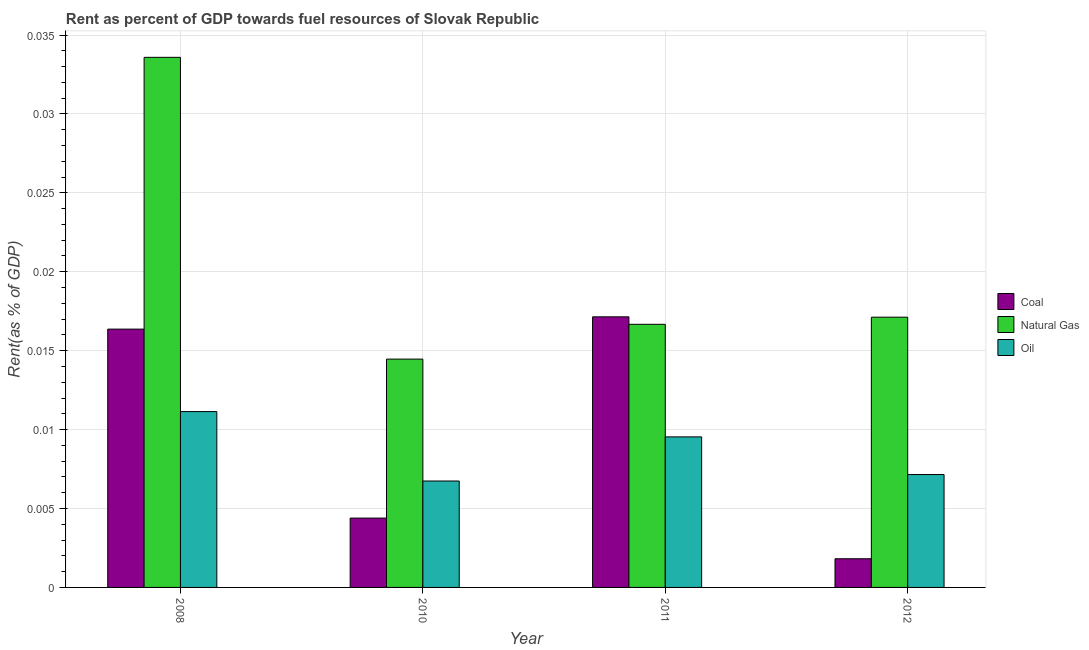Are the number of bars on each tick of the X-axis equal?
Your answer should be very brief. Yes. How many bars are there on the 2nd tick from the left?
Offer a very short reply. 3. How many bars are there on the 1st tick from the right?
Your response must be concise. 3. What is the label of the 2nd group of bars from the left?
Keep it short and to the point. 2010. What is the rent towards coal in 2008?
Your answer should be compact. 0.02. Across all years, what is the maximum rent towards oil?
Your answer should be compact. 0.01. Across all years, what is the minimum rent towards oil?
Your response must be concise. 0.01. In which year was the rent towards coal minimum?
Keep it short and to the point. 2012. What is the total rent towards oil in the graph?
Make the answer very short. 0.03. What is the difference between the rent towards coal in 2008 and that in 2011?
Offer a terse response. -0. What is the difference between the rent towards natural gas in 2011 and the rent towards coal in 2012?
Your answer should be very brief. -0. What is the average rent towards natural gas per year?
Provide a succinct answer. 0.02. What is the ratio of the rent towards oil in 2008 to that in 2010?
Offer a terse response. 1.65. Is the difference between the rent towards natural gas in 2008 and 2010 greater than the difference between the rent towards oil in 2008 and 2010?
Your response must be concise. No. What is the difference between the highest and the second highest rent towards coal?
Your answer should be compact. 0. What is the difference between the highest and the lowest rent towards coal?
Keep it short and to the point. 0.02. What does the 3rd bar from the left in 2010 represents?
Offer a terse response. Oil. What does the 3rd bar from the right in 2008 represents?
Offer a terse response. Coal. Is it the case that in every year, the sum of the rent towards coal and rent towards natural gas is greater than the rent towards oil?
Ensure brevity in your answer.  Yes. Are all the bars in the graph horizontal?
Your answer should be compact. No. What is the difference between two consecutive major ticks on the Y-axis?
Provide a succinct answer. 0.01. Are the values on the major ticks of Y-axis written in scientific E-notation?
Give a very brief answer. No. Does the graph contain any zero values?
Give a very brief answer. No. Where does the legend appear in the graph?
Offer a very short reply. Center right. How many legend labels are there?
Your answer should be very brief. 3. What is the title of the graph?
Provide a short and direct response. Rent as percent of GDP towards fuel resources of Slovak Republic. What is the label or title of the X-axis?
Your response must be concise. Year. What is the label or title of the Y-axis?
Give a very brief answer. Rent(as % of GDP). What is the Rent(as % of GDP) of Coal in 2008?
Offer a terse response. 0.02. What is the Rent(as % of GDP) in Natural Gas in 2008?
Ensure brevity in your answer.  0.03. What is the Rent(as % of GDP) in Oil in 2008?
Your answer should be compact. 0.01. What is the Rent(as % of GDP) in Coal in 2010?
Give a very brief answer. 0. What is the Rent(as % of GDP) of Natural Gas in 2010?
Offer a very short reply. 0.01. What is the Rent(as % of GDP) in Oil in 2010?
Your response must be concise. 0.01. What is the Rent(as % of GDP) of Coal in 2011?
Offer a terse response. 0.02. What is the Rent(as % of GDP) of Natural Gas in 2011?
Keep it short and to the point. 0.02. What is the Rent(as % of GDP) of Oil in 2011?
Ensure brevity in your answer.  0.01. What is the Rent(as % of GDP) in Coal in 2012?
Provide a short and direct response. 0. What is the Rent(as % of GDP) of Natural Gas in 2012?
Offer a terse response. 0.02. What is the Rent(as % of GDP) in Oil in 2012?
Offer a very short reply. 0.01. Across all years, what is the maximum Rent(as % of GDP) of Coal?
Make the answer very short. 0.02. Across all years, what is the maximum Rent(as % of GDP) of Natural Gas?
Provide a succinct answer. 0.03. Across all years, what is the maximum Rent(as % of GDP) of Oil?
Keep it short and to the point. 0.01. Across all years, what is the minimum Rent(as % of GDP) in Coal?
Offer a very short reply. 0. Across all years, what is the minimum Rent(as % of GDP) in Natural Gas?
Provide a succinct answer. 0.01. Across all years, what is the minimum Rent(as % of GDP) in Oil?
Give a very brief answer. 0.01. What is the total Rent(as % of GDP) of Coal in the graph?
Your response must be concise. 0.04. What is the total Rent(as % of GDP) in Natural Gas in the graph?
Keep it short and to the point. 0.08. What is the total Rent(as % of GDP) in Oil in the graph?
Keep it short and to the point. 0.03. What is the difference between the Rent(as % of GDP) in Coal in 2008 and that in 2010?
Provide a succinct answer. 0.01. What is the difference between the Rent(as % of GDP) in Natural Gas in 2008 and that in 2010?
Make the answer very short. 0.02. What is the difference between the Rent(as % of GDP) of Oil in 2008 and that in 2010?
Offer a very short reply. 0. What is the difference between the Rent(as % of GDP) of Coal in 2008 and that in 2011?
Offer a very short reply. -0. What is the difference between the Rent(as % of GDP) of Natural Gas in 2008 and that in 2011?
Keep it short and to the point. 0.02. What is the difference between the Rent(as % of GDP) in Oil in 2008 and that in 2011?
Provide a succinct answer. 0. What is the difference between the Rent(as % of GDP) in Coal in 2008 and that in 2012?
Your answer should be very brief. 0.01. What is the difference between the Rent(as % of GDP) in Natural Gas in 2008 and that in 2012?
Make the answer very short. 0.02. What is the difference between the Rent(as % of GDP) of Oil in 2008 and that in 2012?
Your answer should be very brief. 0. What is the difference between the Rent(as % of GDP) of Coal in 2010 and that in 2011?
Keep it short and to the point. -0.01. What is the difference between the Rent(as % of GDP) of Natural Gas in 2010 and that in 2011?
Your answer should be very brief. -0. What is the difference between the Rent(as % of GDP) of Oil in 2010 and that in 2011?
Your answer should be very brief. -0. What is the difference between the Rent(as % of GDP) in Coal in 2010 and that in 2012?
Your answer should be compact. 0. What is the difference between the Rent(as % of GDP) of Natural Gas in 2010 and that in 2012?
Ensure brevity in your answer.  -0. What is the difference between the Rent(as % of GDP) of Oil in 2010 and that in 2012?
Provide a short and direct response. -0. What is the difference between the Rent(as % of GDP) of Coal in 2011 and that in 2012?
Make the answer very short. 0.02. What is the difference between the Rent(as % of GDP) in Natural Gas in 2011 and that in 2012?
Provide a succinct answer. -0. What is the difference between the Rent(as % of GDP) of Oil in 2011 and that in 2012?
Provide a succinct answer. 0. What is the difference between the Rent(as % of GDP) in Coal in 2008 and the Rent(as % of GDP) in Natural Gas in 2010?
Offer a terse response. 0. What is the difference between the Rent(as % of GDP) in Coal in 2008 and the Rent(as % of GDP) in Oil in 2010?
Your answer should be compact. 0.01. What is the difference between the Rent(as % of GDP) in Natural Gas in 2008 and the Rent(as % of GDP) in Oil in 2010?
Provide a short and direct response. 0.03. What is the difference between the Rent(as % of GDP) in Coal in 2008 and the Rent(as % of GDP) in Natural Gas in 2011?
Offer a very short reply. -0. What is the difference between the Rent(as % of GDP) of Coal in 2008 and the Rent(as % of GDP) of Oil in 2011?
Ensure brevity in your answer.  0.01. What is the difference between the Rent(as % of GDP) in Natural Gas in 2008 and the Rent(as % of GDP) in Oil in 2011?
Offer a very short reply. 0.02. What is the difference between the Rent(as % of GDP) of Coal in 2008 and the Rent(as % of GDP) of Natural Gas in 2012?
Give a very brief answer. -0. What is the difference between the Rent(as % of GDP) of Coal in 2008 and the Rent(as % of GDP) of Oil in 2012?
Provide a succinct answer. 0.01. What is the difference between the Rent(as % of GDP) in Natural Gas in 2008 and the Rent(as % of GDP) in Oil in 2012?
Your answer should be compact. 0.03. What is the difference between the Rent(as % of GDP) of Coal in 2010 and the Rent(as % of GDP) of Natural Gas in 2011?
Keep it short and to the point. -0.01. What is the difference between the Rent(as % of GDP) of Coal in 2010 and the Rent(as % of GDP) of Oil in 2011?
Your answer should be compact. -0.01. What is the difference between the Rent(as % of GDP) in Natural Gas in 2010 and the Rent(as % of GDP) in Oil in 2011?
Give a very brief answer. 0. What is the difference between the Rent(as % of GDP) in Coal in 2010 and the Rent(as % of GDP) in Natural Gas in 2012?
Make the answer very short. -0.01. What is the difference between the Rent(as % of GDP) in Coal in 2010 and the Rent(as % of GDP) in Oil in 2012?
Offer a terse response. -0. What is the difference between the Rent(as % of GDP) of Natural Gas in 2010 and the Rent(as % of GDP) of Oil in 2012?
Make the answer very short. 0.01. What is the difference between the Rent(as % of GDP) in Coal in 2011 and the Rent(as % of GDP) in Oil in 2012?
Ensure brevity in your answer.  0.01. What is the difference between the Rent(as % of GDP) in Natural Gas in 2011 and the Rent(as % of GDP) in Oil in 2012?
Your response must be concise. 0.01. What is the average Rent(as % of GDP) in Coal per year?
Make the answer very short. 0.01. What is the average Rent(as % of GDP) of Natural Gas per year?
Offer a very short reply. 0.02. What is the average Rent(as % of GDP) in Oil per year?
Your answer should be compact. 0.01. In the year 2008, what is the difference between the Rent(as % of GDP) in Coal and Rent(as % of GDP) in Natural Gas?
Ensure brevity in your answer.  -0.02. In the year 2008, what is the difference between the Rent(as % of GDP) of Coal and Rent(as % of GDP) of Oil?
Provide a succinct answer. 0.01. In the year 2008, what is the difference between the Rent(as % of GDP) of Natural Gas and Rent(as % of GDP) of Oil?
Provide a succinct answer. 0.02. In the year 2010, what is the difference between the Rent(as % of GDP) of Coal and Rent(as % of GDP) of Natural Gas?
Keep it short and to the point. -0.01. In the year 2010, what is the difference between the Rent(as % of GDP) in Coal and Rent(as % of GDP) in Oil?
Your response must be concise. -0. In the year 2010, what is the difference between the Rent(as % of GDP) of Natural Gas and Rent(as % of GDP) of Oil?
Provide a succinct answer. 0.01. In the year 2011, what is the difference between the Rent(as % of GDP) in Coal and Rent(as % of GDP) in Oil?
Offer a terse response. 0.01. In the year 2011, what is the difference between the Rent(as % of GDP) in Natural Gas and Rent(as % of GDP) in Oil?
Your response must be concise. 0.01. In the year 2012, what is the difference between the Rent(as % of GDP) in Coal and Rent(as % of GDP) in Natural Gas?
Your answer should be compact. -0.02. In the year 2012, what is the difference between the Rent(as % of GDP) in Coal and Rent(as % of GDP) in Oil?
Your response must be concise. -0.01. What is the ratio of the Rent(as % of GDP) of Coal in 2008 to that in 2010?
Your response must be concise. 3.73. What is the ratio of the Rent(as % of GDP) of Natural Gas in 2008 to that in 2010?
Provide a succinct answer. 2.32. What is the ratio of the Rent(as % of GDP) of Oil in 2008 to that in 2010?
Give a very brief answer. 1.65. What is the ratio of the Rent(as % of GDP) in Coal in 2008 to that in 2011?
Provide a succinct answer. 0.95. What is the ratio of the Rent(as % of GDP) in Natural Gas in 2008 to that in 2011?
Give a very brief answer. 2.01. What is the ratio of the Rent(as % of GDP) in Oil in 2008 to that in 2011?
Offer a terse response. 1.17. What is the ratio of the Rent(as % of GDP) in Coal in 2008 to that in 2012?
Keep it short and to the point. 9.01. What is the ratio of the Rent(as % of GDP) of Natural Gas in 2008 to that in 2012?
Give a very brief answer. 1.96. What is the ratio of the Rent(as % of GDP) of Oil in 2008 to that in 2012?
Your answer should be very brief. 1.56. What is the ratio of the Rent(as % of GDP) of Coal in 2010 to that in 2011?
Make the answer very short. 0.26. What is the ratio of the Rent(as % of GDP) of Natural Gas in 2010 to that in 2011?
Your response must be concise. 0.87. What is the ratio of the Rent(as % of GDP) of Oil in 2010 to that in 2011?
Your answer should be very brief. 0.71. What is the ratio of the Rent(as % of GDP) in Coal in 2010 to that in 2012?
Give a very brief answer. 2.42. What is the ratio of the Rent(as % of GDP) in Natural Gas in 2010 to that in 2012?
Keep it short and to the point. 0.84. What is the ratio of the Rent(as % of GDP) of Oil in 2010 to that in 2012?
Your answer should be compact. 0.94. What is the ratio of the Rent(as % of GDP) of Coal in 2011 to that in 2012?
Give a very brief answer. 9.44. What is the ratio of the Rent(as % of GDP) in Natural Gas in 2011 to that in 2012?
Offer a terse response. 0.97. What is the ratio of the Rent(as % of GDP) in Oil in 2011 to that in 2012?
Provide a short and direct response. 1.33. What is the difference between the highest and the second highest Rent(as % of GDP) in Coal?
Offer a very short reply. 0. What is the difference between the highest and the second highest Rent(as % of GDP) of Natural Gas?
Provide a succinct answer. 0.02. What is the difference between the highest and the second highest Rent(as % of GDP) in Oil?
Give a very brief answer. 0. What is the difference between the highest and the lowest Rent(as % of GDP) of Coal?
Provide a short and direct response. 0.02. What is the difference between the highest and the lowest Rent(as % of GDP) in Natural Gas?
Ensure brevity in your answer.  0.02. What is the difference between the highest and the lowest Rent(as % of GDP) in Oil?
Provide a short and direct response. 0. 